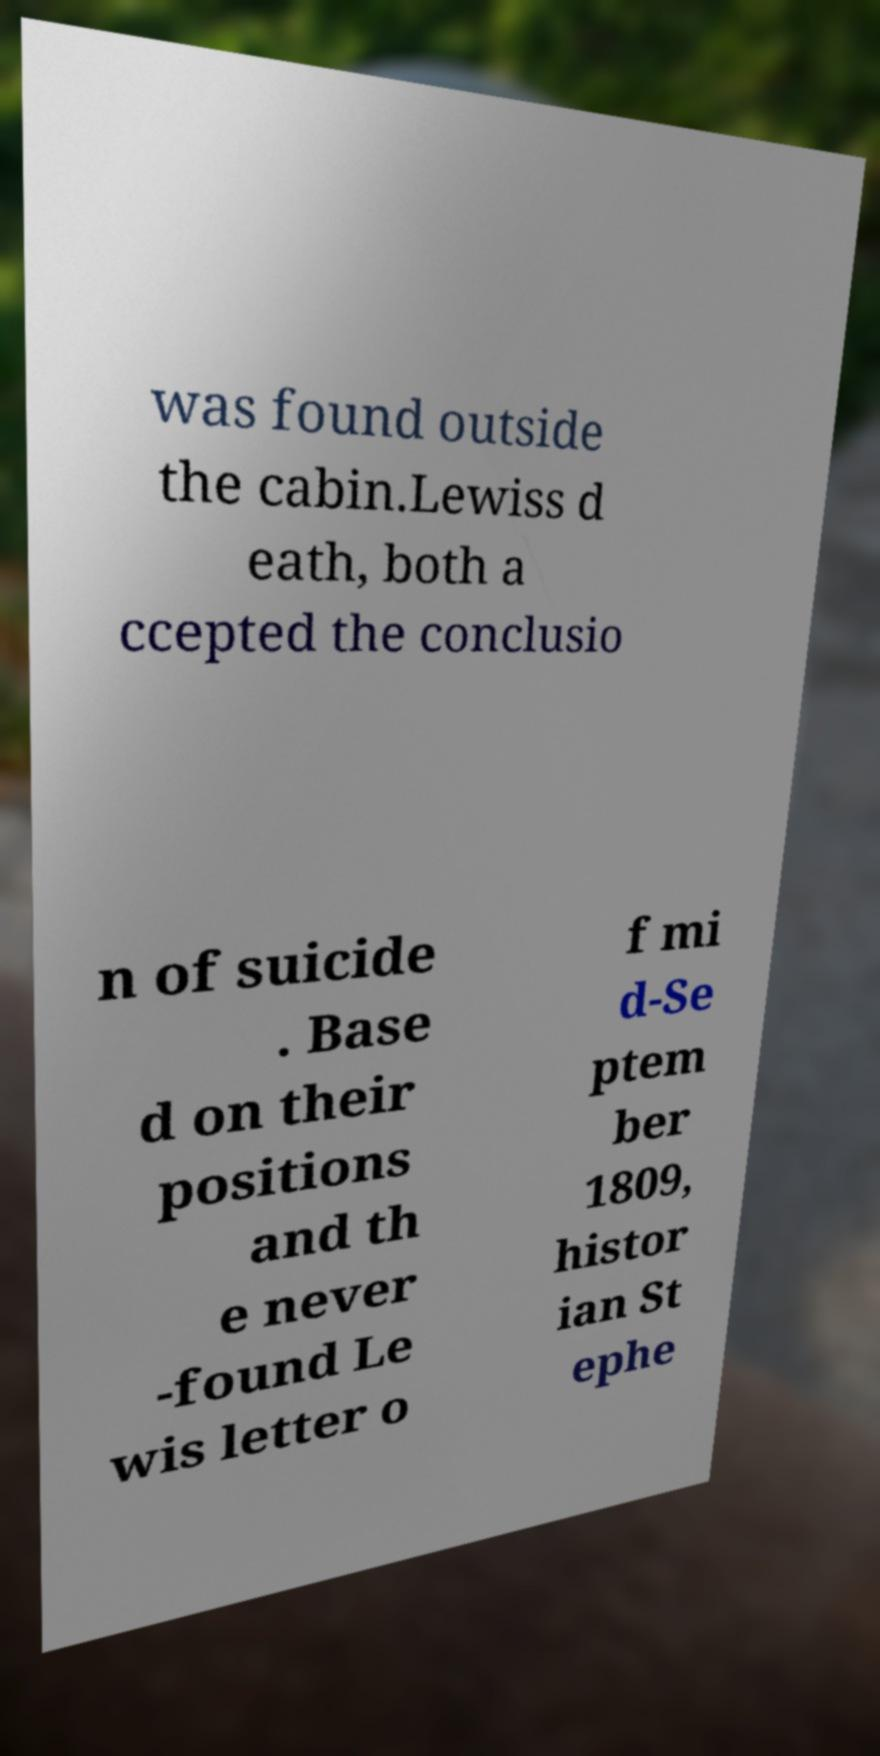Can you accurately transcribe the text from the provided image for me? was found outside the cabin.Lewiss d eath, both a ccepted the conclusio n of suicide . Base d on their positions and th e never -found Le wis letter o f mi d-Se ptem ber 1809, histor ian St ephe 